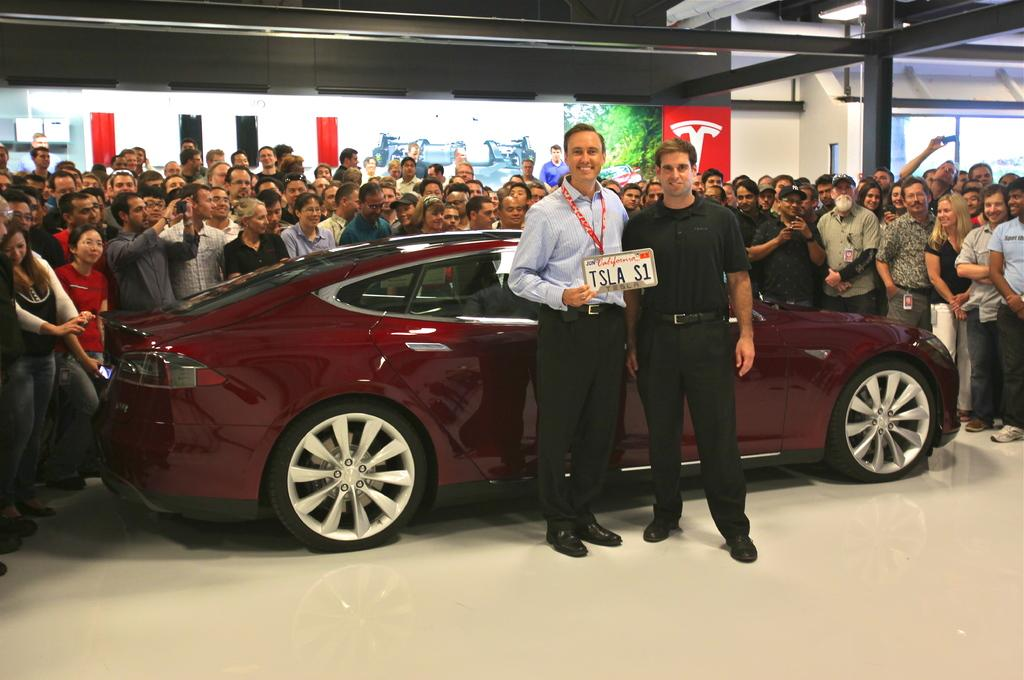How many people are visible in the image? There are 2 people standing in the image. What is the person on the left holding? The person on the left is holding a board. What can be seen in the background of the image? There is a car in the image. Are there any other people visible in the image besides the two standing in front? Yes, there are people standing behind the two people. What type of bag is hanging from the stem of the car in the image? There is no bag or stem present in the image; it only features a car in the background. 